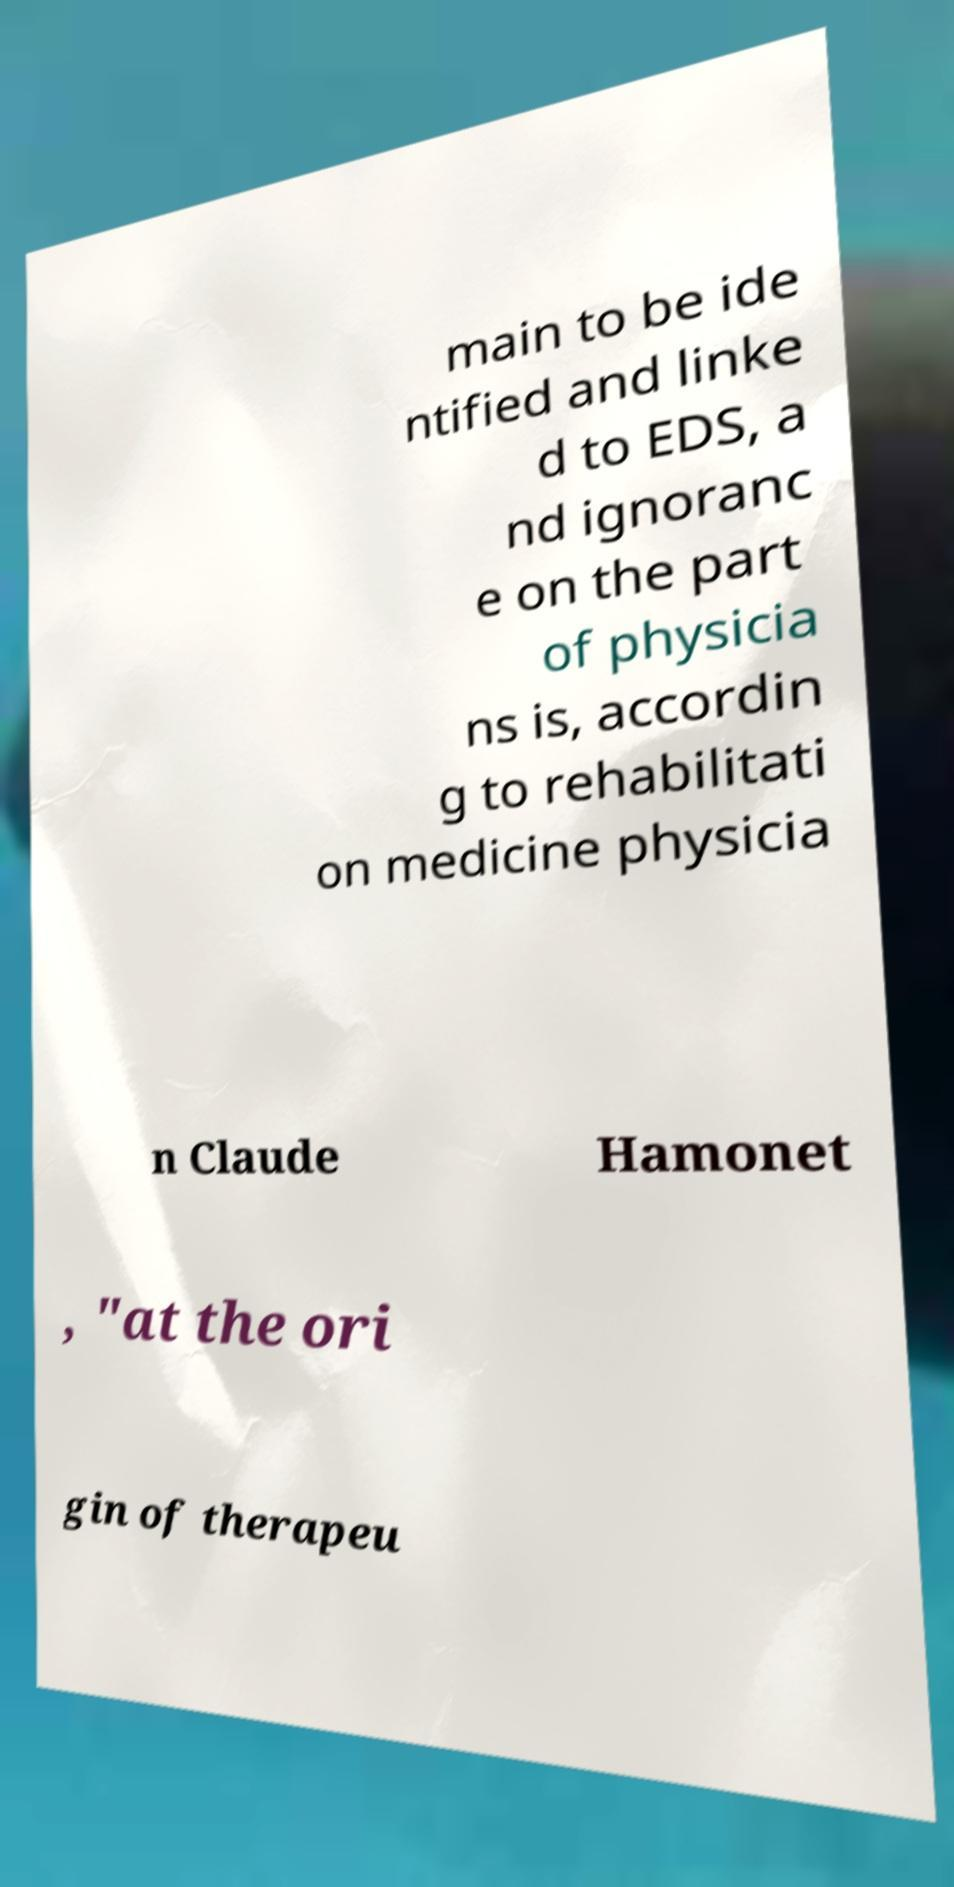Can you accurately transcribe the text from the provided image for me? main to be ide ntified and linke d to EDS, a nd ignoranc e on the part of physicia ns is, accordin g to rehabilitati on medicine physicia n Claude Hamonet , "at the ori gin of therapeu 